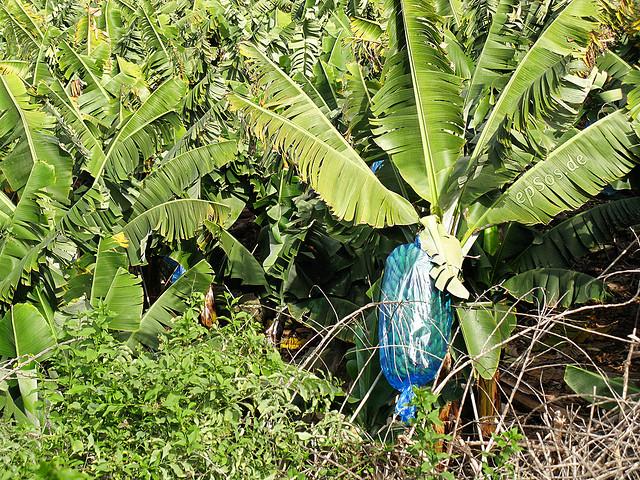What is the blue object hanging?
Quick response, please. Bag. Is this jungle-like?
Concise answer only. Yes. How tall are these trees?
Concise answer only. Short. Are these banana trees?
Be succinct. Yes. 